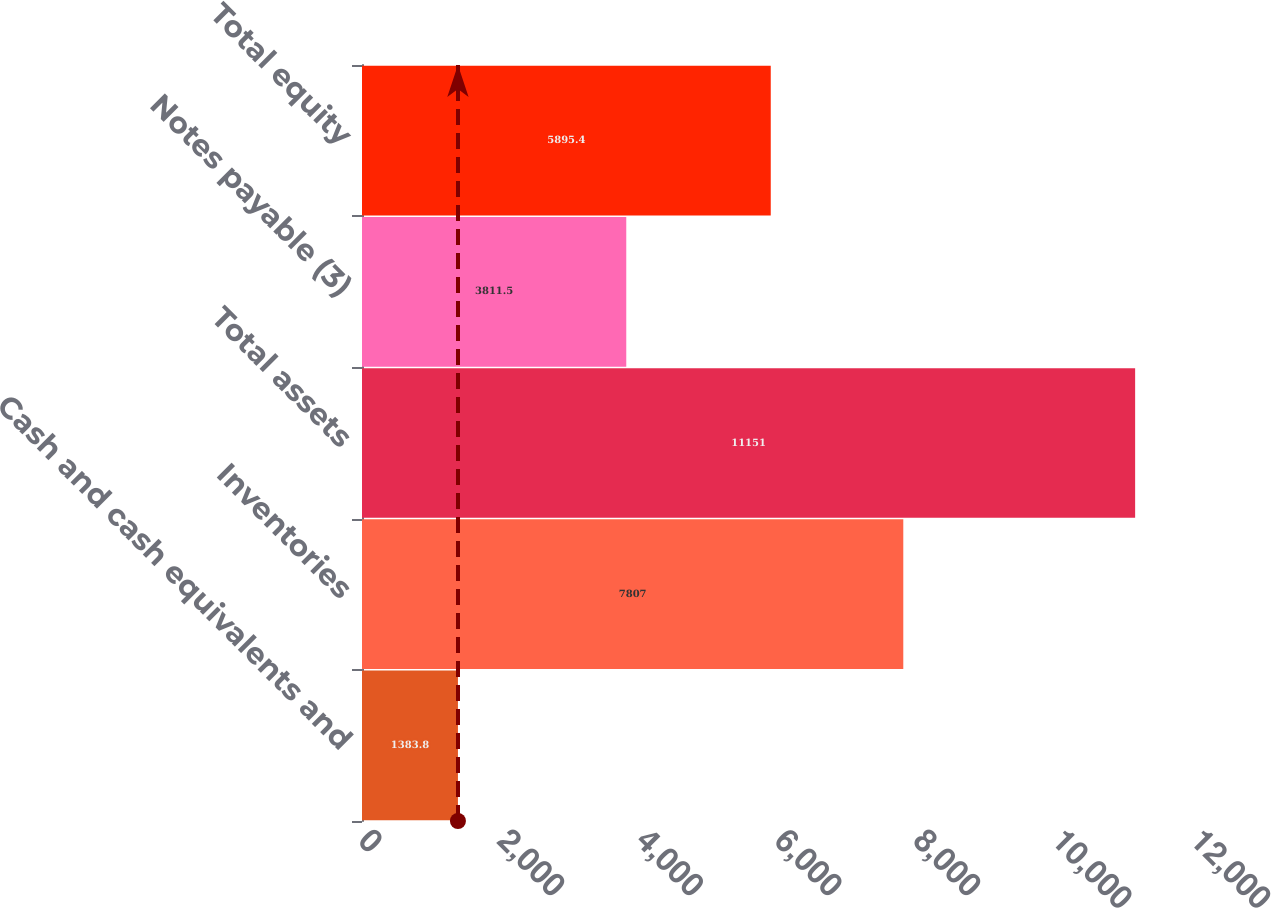Convert chart to OTSL. <chart><loc_0><loc_0><loc_500><loc_500><bar_chart><fcel>Cash and cash equivalents and<fcel>Inventories<fcel>Total assets<fcel>Notes payable (3)<fcel>Total equity<nl><fcel>1383.8<fcel>7807<fcel>11151<fcel>3811.5<fcel>5895.4<nl></chart> 